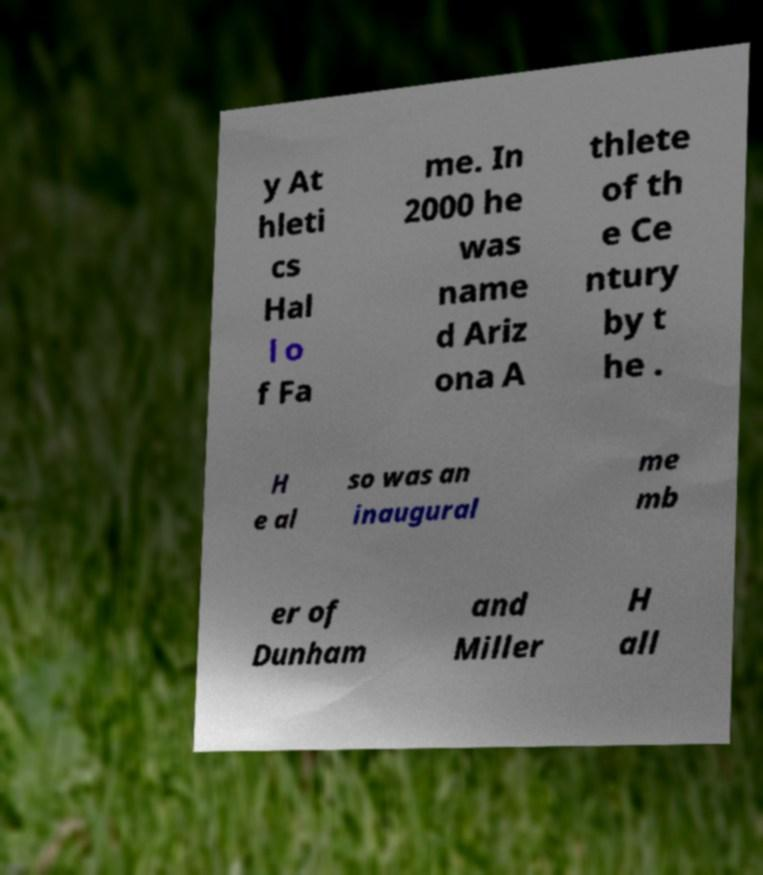Please read and relay the text visible in this image. What does it say? y At hleti cs Hal l o f Fa me. In 2000 he was name d Ariz ona A thlete of th e Ce ntury by t he . H e al so was an inaugural me mb er of Dunham and Miller H all 